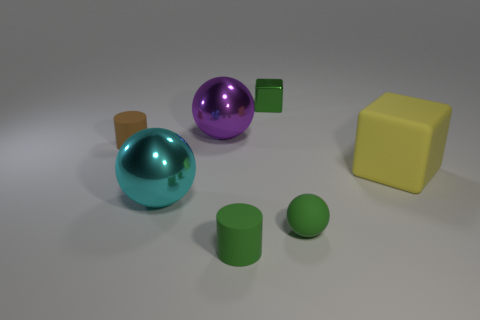Can you describe the texture of the objects and the surface they are on? Certainly! The two spheres appear to have smooth textures, reflecting their surroundings because of their glossy finish. The cube and the cylinders have a matte finish, indicating a rougher surface texture. The surface upon which the objects rest seems to be a matte finish with slight textural variations, resulting in soft shadows and subtle reflections rather than sharp or crisp ones. 